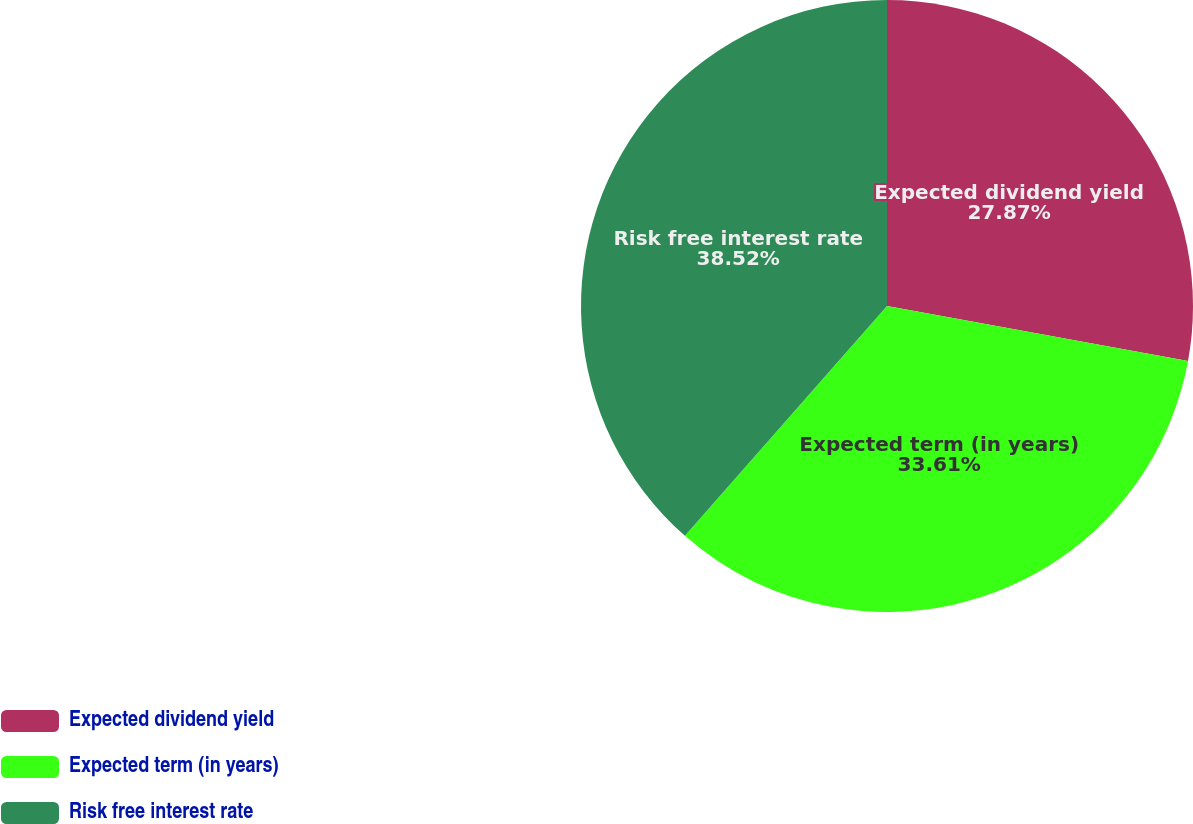Convert chart. <chart><loc_0><loc_0><loc_500><loc_500><pie_chart><fcel>Expected dividend yield<fcel>Expected term (in years)<fcel>Risk free interest rate<nl><fcel>27.87%<fcel>33.61%<fcel>38.52%<nl></chart> 